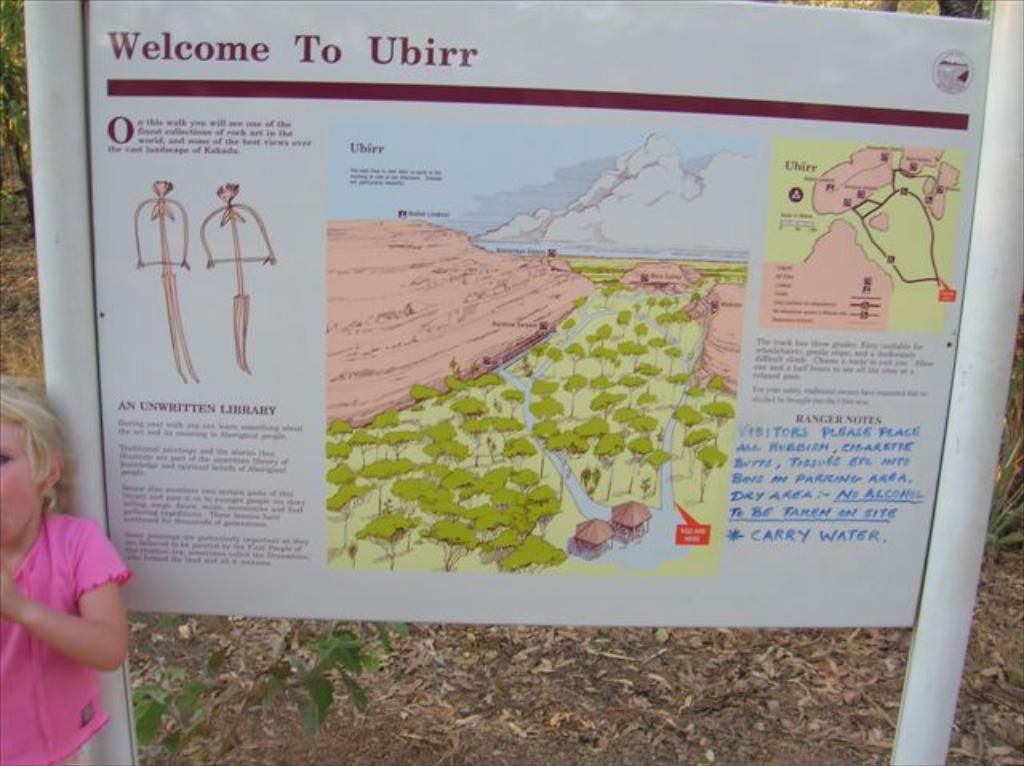Describe this image in one or two sentences. In this image I see a girl over here who is wearing pink top and I see a white board on which there is a map and I see words written and I see the sketches over here and I see the ground on which there are leaves and in the background I see the green leaves. 